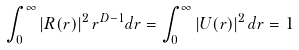Convert formula to latex. <formula><loc_0><loc_0><loc_500><loc_500>\int _ { 0 } ^ { \infty } \left | R ( r ) \right | ^ { 2 } r ^ { D - 1 } d r = \int _ { 0 } ^ { \infty } \left | U ( r ) \right | ^ { 2 } d r = 1</formula> 